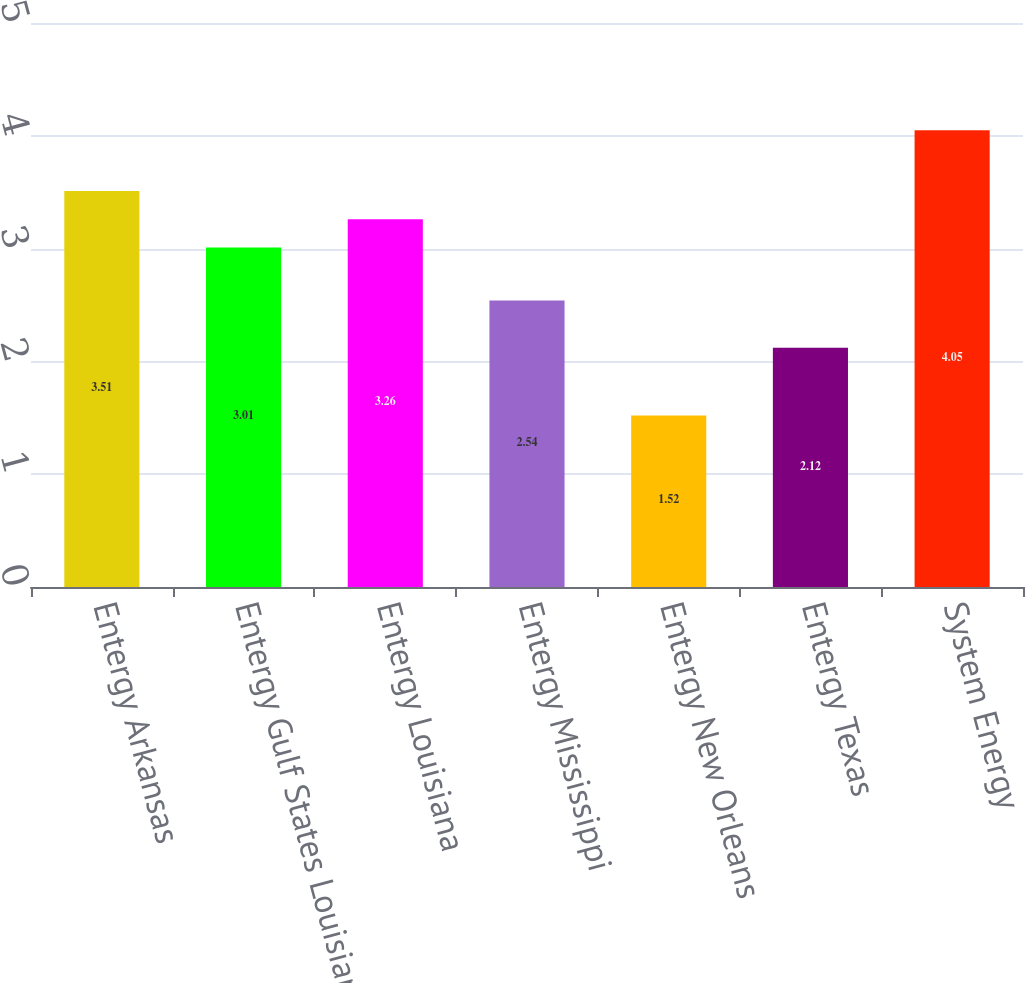<chart> <loc_0><loc_0><loc_500><loc_500><bar_chart><fcel>Entergy Arkansas<fcel>Entergy Gulf States Louisiana<fcel>Entergy Louisiana<fcel>Entergy Mississippi<fcel>Entergy New Orleans<fcel>Entergy Texas<fcel>System Energy<nl><fcel>3.51<fcel>3.01<fcel>3.26<fcel>2.54<fcel>1.52<fcel>2.12<fcel>4.05<nl></chart> 